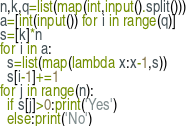Convert code to text. <code><loc_0><loc_0><loc_500><loc_500><_Python_>n,k,q=list(map(int,input().split()))
a=[int(input()) for i in range(q)]
s=[k]*n
for i in a:
  s=list(map(lambda x:x-1,s))
  s[i-1]+=1
for j in range(n):
  if s[j]>0:print('Yes')
  else:print('No')</code> 